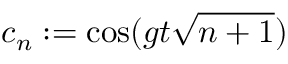<formula> <loc_0><loc_0><loc_500><loc_500>c _ { n } \colon = \cos ( g t \sqrt { n + 1 } )</formula> 